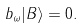<formula> <loc_0><loc_0><loc_500><loc_500>b _ { \omega } | B \rangle = 0 .</formula> 